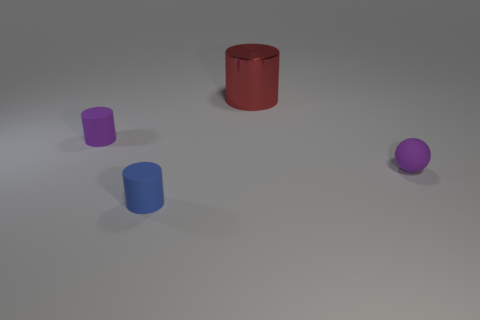Add 1 small purple things. How many objects exist? 5 Subtract all spheres. How many objects are left? 3 Subtract 0 brown cylinders. How many objects are left? 4 Subtract all tiny cyan rubber blocks. Subtract all purple cylinders. How many objects are left? 3 Add 4 cylinders. How many cylinders are left? 7 Add 1 small balls. How many small balls exist? 2 